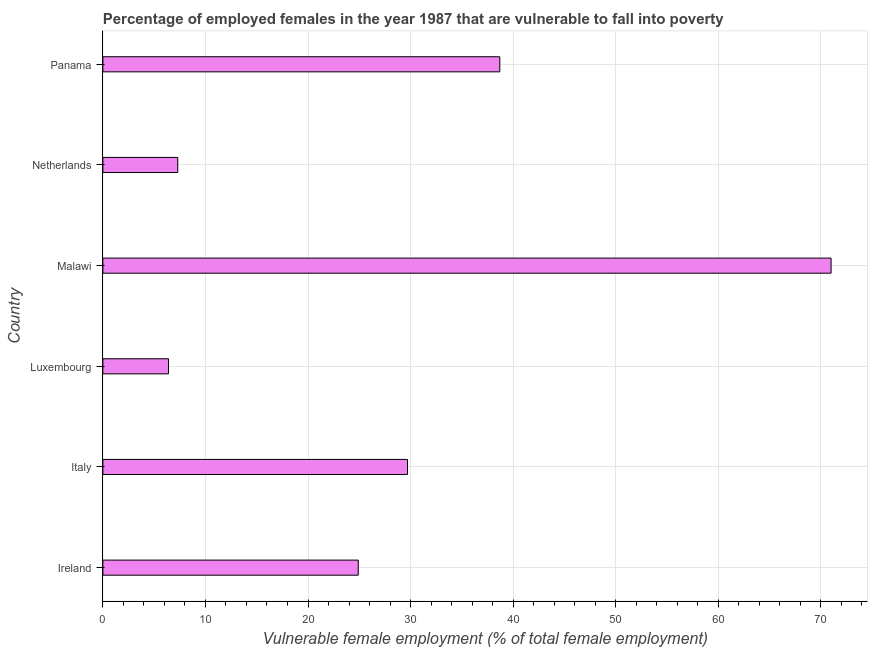Does the graph contain any zero values?
Your answer should be compact. No. What is the title of the graph?
Ensure brevity in your answer.  Percentage of employed females in the year 1987 that are vulnerable to fall into poverty. What is the label or title of the X-axis?
Offer a terse response. Vulnerable female employment (% of total female employment). What is the label or title of the Y-axis?
Offer a terse response. Country. What is the percentage of employed females who are vulnerable to fall into poverty in Luxembourg?
Offer a very short reply. 6.4. Across all countries, what is the maximum percentage of employed females who are vulnerable to fall into poverty?
Give a very brief answer. 71. Across all countries, what is the minimum percentage of employed females who are vulnerable to fall into poverty?
Ensure brevity in your answer.  6.4. In which country was the percentage of employed females who are vulnerable to fall into poverty maximum?
Keep it short and to the point. Malawi. In which country was the percentage of employed females who are vulnerable to fall into poverty minimum?
Give a very brief answer. Luxembourg. What is the sum of the percentage of employed females who are vulnerable to fall into poverty?
Keep it short and to the point. 178. What is the difference between the percentage of employed females who are vulnerable to fall into poverty in Italy and Malawi?
Make the answer very short. -41.3. What is the average percentage of employed females who are vulnerable to fall into poverty per country?
Ensure brevity in your answer.  29.67. What is the median percentage of employed females who are vulnerable to fall into poverty?
Give a very brief answer. 27.3. In how many countries, is the percentage of employed females who are vulnerable to fall into poverty greater than 64 %?
Make the answer very short. 1. What is the ratio of the percentage of employed females who are vulnerable to fall into poverty in Italy to that in Netherlands?
Keep it short and to the point. 4.07. Is the percentage of employed females who are vulnerable to fall into poverty in Netherlands less than that in Panama?
Give a very brief answer. Yes. Is the difference between the percentage of employed females who are vulnerable to fall into poverty in Ireland and Panama greater than the difference between any two countries?
Your response must be concise. No. What is the difference between the highest and the second highest percentage of employed females who are vulnerable to fall into poverty?
Give a very brief answer. 32.3. Is the sum of the percentage of employed females who are vulnerable to fall into poverty in Ireland and Luxembourg greater than the maximum percentage of employed females who are vulnerable to fall into poverty across all countries?
Keep it short and to the point. No. What is the difference between the highest and the lowest percentage of employed females who are vulnerable to fall into poverty?
Keep it short and to the point. 64.6. In how many countries, is the percentage of employed females who are vulnerable to fall into poverty greater than the average percentage of employed females who are vulnerable to fall into poverty taken over all countries?
Provide a short and direct response. 3. How many bars are there?
Provide a succinct answer. 6. What is the difference between two consecutive major ticks on the X-axis?
Your response must be concise. 10. Are the values on the major ticks of X-axis written in scientific E-notation?
Offer a terse response. No. What is the Vulnerable female employment (% of total female employment) in Ireland?
Your response must be concise. 24.9. What is the Vulnerable female employment (% of total female employment) in Italy?
Offer a terse response. 29.7. What is the Vulnerable female employment (% of total female employment) of Luxembourg?
Ensure brevity in your answer.  6.4. What is the Vulnerable female employment (% of total female employment) of Netherlands?
Make the answer very short. 7.3. What is the Vulnerable female employment (% of total female employment) of Panama?
Make the answer very short. 38.7. What is the difference between the Vulnerable female employment (% of total female employment) in Ireland and Luxembourg?
Make the answer very short. 18.5. What is the difference between the Vulnerable female employment (% of total female employment) in Ireland and Malawi?
Give a very brief answer. -46.1. What is the difference between the Vulnerable female employment (% of total female employment) in Italy and Luxembourg?
Your answer should be very brief. 23.3. What is the difference between the Vulnerable female employment (% of total female employment) in Italy and Malawi?
Your answer should be compact. -41.3. What is the difference between the Vulnerable female employment (% of total female employment) in Italy and Netherlands?
Your response must be concise. 22.4. What is the difference between the Vulnerable female employment (% of total female employment) in Italy and Panama?
Keep it short and to the point. -9. What is the difference between the Vulnerable female employment (% of total female employment) in Luxembourg and Malawi?
Make the answer very short. -64.6. What is the difference between the Vulnerable female employment (% of total female employment) in Luxembourg and Netherlands?
Ensure brevity in your answer.  -0.9. What is the difference between the Vulnerable female employment (% of total female employment) in Luxembourg and Panama?
Offer a very short reply. -32.3. What is the difference between the Vulnerable female employment (% of total female employment) in Malawi and Netherlands?
Your answer should be very brief. 63.7. What is the difference between the Vulnerable female employment (% of total female employment) in Malawi and Panama?
Provide a succinct answer. 32.3. What is the difference between the Vulnerable female employment (% of total female employment) in Netherlands and Panama?
Offer a terse response. -31.4. What is the ratio of the Vulnerable female employment (% of total female employment) in Ireland to that in Italy?
Keep it short and to the point. 0.84. What is the ratio of the Vulnerable female employment (% of total female employment) in Ireland to that in Luxembourg?
Make the answer very short. 3.89. What is the ratio of the Vulnerable female employment (% of total female employment) in Ireland to that in Malawi?
Your response must be concise. 0.35. What is the ratio of the Vulnerable female employment (% of total female employment) in Ireland to that in Netherlands?
Offer a terse response. 3.41. What is the ratio of the Vulnerable female employment (% of total female employment) in Ireland to that in Panama?
Offer a very short reply. 0.64. What is the ratio of the Vulnerable female employment (% of total female employment) in Italy to that in Luxembourg?
Ensure brevity in your answer.  4.64. What is the ratio of the Vulnerable female employment (% of total female employment) in Italy to that in Malawi?
Your response must be concise. 0.42. What is the ratio of the Vulnerable female employment (% of total female employment) in Italy to that in Netherlands?
Keep it short and to the point. 4.07. What is the ratio of the Vulnerable female employment (% of total female employment) in Italy to that in Panama?
Provide a short and direct response. 0.77. What is the ratio of the Vulnerable female employment (% of total female employment) in Luxembourg to that in Malawi?
Provide a short and direct response. 0.09. What is the ratio of the Vulnerable female employment (% of total female employment) in Luxembourg to that in Netherlands?
Offer a very short reply. 0.88. What is the ratio of the Vulnerable female employment (% of total female employment) in Luxembourg to that in Panama?
Offer a very short reply. 0.17. What is the ratio of the Vulnerable female employment (% of total female employment) in Malawi to that in Netherlands?
Offer a very short reply. 9.73. What is the ratio of the Vulnerable female employment (% of total female employment) in Malawi to that in Panama?
Provide a succinct answer. 1.83. What is the ratio of the Vulnerable female employment (% of total female employment) in Netherlands to that in Panama?
Provide a short and direct response. 0.19. 